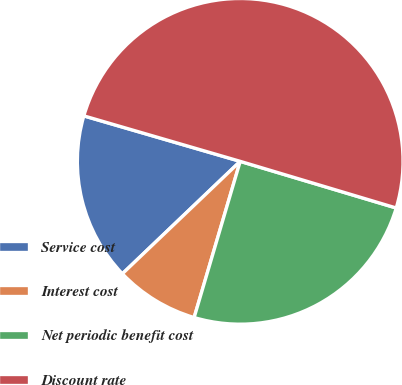Convert chart. <chart><loc_0><loc_0><loc_500><loc_500><pie_chart><fcel>Service cost<fcel>Interest cost<fcel>Net periodic benefit cost<fcel>Discount rate<nl><fcel>16.63%<fcel>8.31%<fcel>24.94%<fcel>50.12%<nl></chart> 